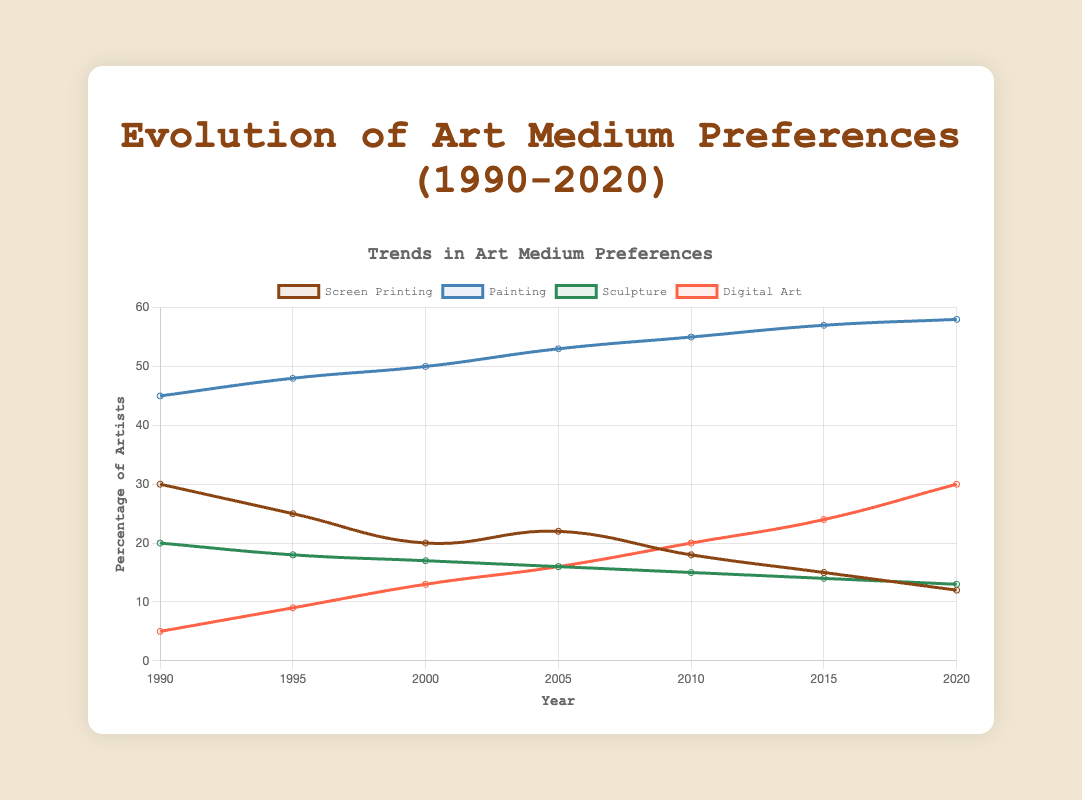How did the preference for Screen Printing change from 1990 to 2020? Observing the chart, the preference for Screen Printing started at 30% in 1990 and gradually declined to 12% in 2020. This shows a steady decrease over the years.
Answer: Decreased In which year did Painting surpass 50% in preference? From the chart, it is evident that the preference for Painting crossed the 50% mark between 2000 (50%) and 2005 (53%). Therefore, the year is 2005.
Answer: 2005 Which art medium saw the most significant increase in preference from 1990 to 2020? Digital Art had the most considerable increase, starting at 5% in 1990 and reaching 30% in 2020. This indicates a rise of 25 percentage points over the period.
Answer: Digital Art How did the trends in Sculpture compare to those in Screen Printing between 1990 and 2020? Both Sculpture and Screen Printing saw a decrease in preference. Screen Printing decreased from 30% to 12%, and Sculpture decreased from 20% to 13%. While both declined, Screen Printing fell more sharply.
Answer: Both decreased; Screen Printing decreased more What is the difference in percentage points between Painting and Digital Art in 2020? In 2020, the preference for Painting was 58%, and for Digital Art, it was 30%. Subtracting the two gives a difference of 28 percentage points.
Answer: 28 What was the trend for Sculpture from 1990 to 2020? The chart shows a gradual decline in the preference for Sculpture, starting at 20% in 1990 and decreasing steadily to 13% in 2020.
Answer: Declined How did the preferences for Painting and Digital Art change relative to each other from 2005 to 2020? Between 2005 and 2020, Painting consistently increased from 53% to 58%, while Digital Art also rose from 16% to 30%. Both increased, but Painting remained higher throughout this period.
Answer: Both increased, Painting remained higher If you average the preferences for Screen Printing and Sculpture in 2010, what value do you get? In 2010, the preference for Screen Printing was 18% and for Sculpture, it was 15%. The average of these two values is (18 + 15) / 2 = 16.5%.
Answer: 16.5 What overall pattern can be observed in the preference for Painting from 1990 to 2020? The preference for Painting shows a consistent upward trend throughout the years, starting at 45% in 1990 and reaching 58% in 2020.
Answer: Increasing Which medium had the lowest percentage in 1995 and what was it? In 1995, Digital Art had the lowest preference at 9%.
Answer: Digital Art, 9% 